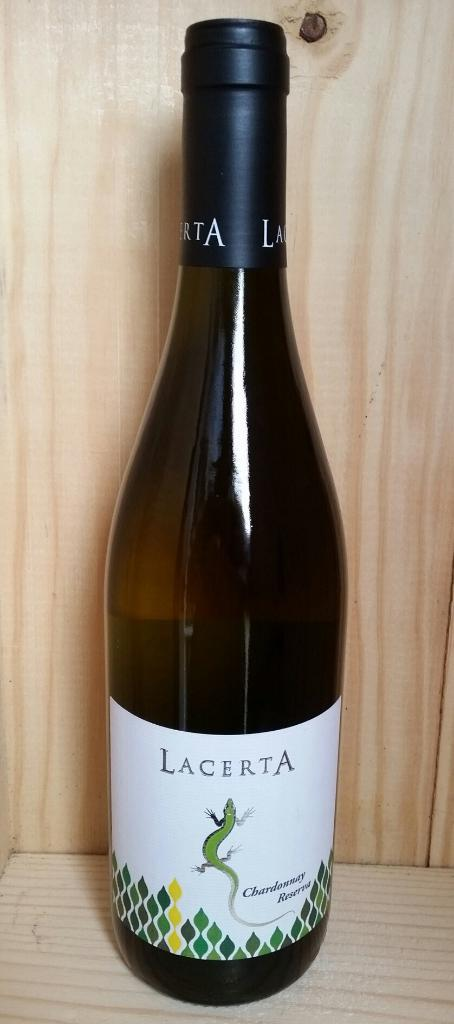<image>
Relay a brief, clear account of the picture shown. Green tall bottle of Lacerta wine that is new 